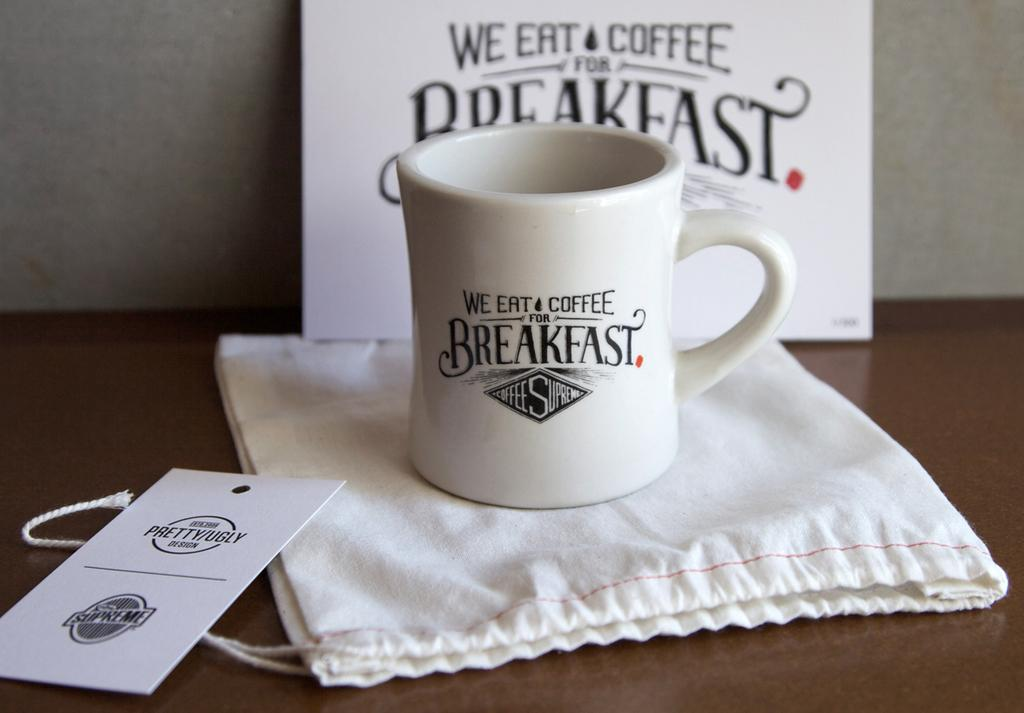Provide a one-sentence caption for the provided image. A mug that says We Eat Coffee for Breakfast. 